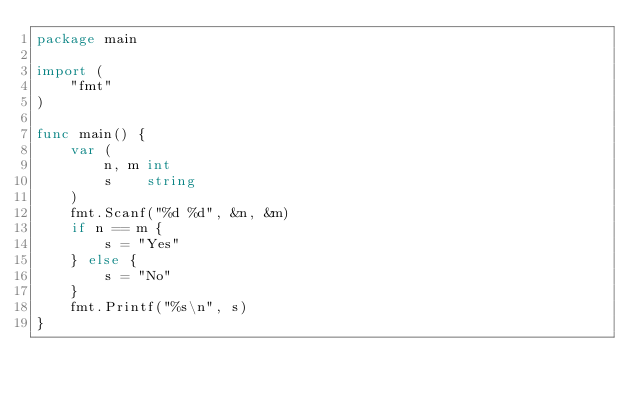Convert code to text. <code><loc_0><loc_0><loc_500><loc_500><_Go_>package main

import (
	"fmt"
)

func main() {
	var (
		n, m int
		s    string
	)
	fmt.Scanf("%d %d", &n, &m)
	if n == m {
		s = "Yes"
	} else {
		s = "No"
	}
	fmt.Printf("%s\n", s)
}
</code> 